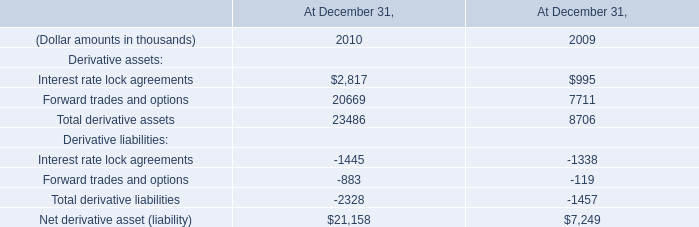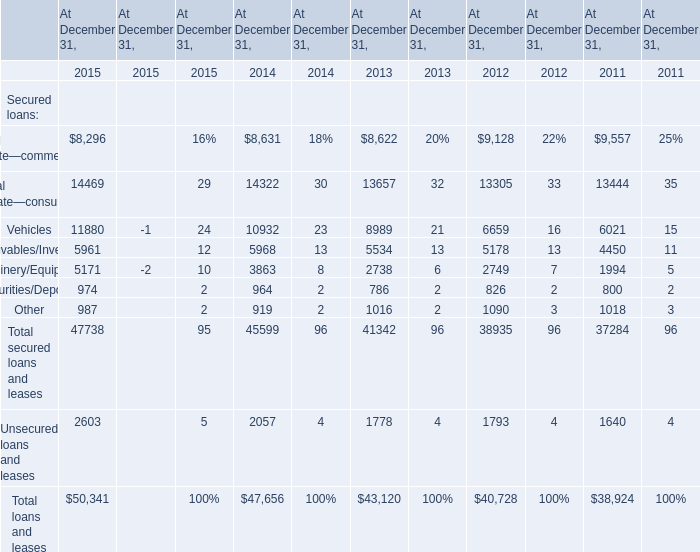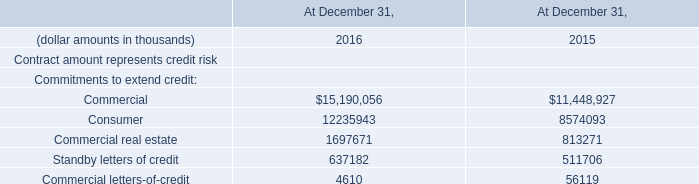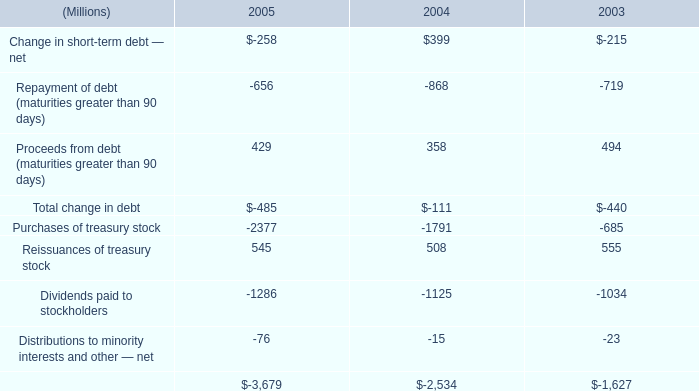What is the sum of Dividends paid to stockholders of 2005, and Machinery/Equipment of At December 31, 2012 ? 
Computations: (1286.0 + 2749.0)
Answer: 4035.0. 